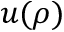Convert formula to latex. <formula><loc_0><loc_0><loc_500><loc_500>u ( \rho )</formula> 